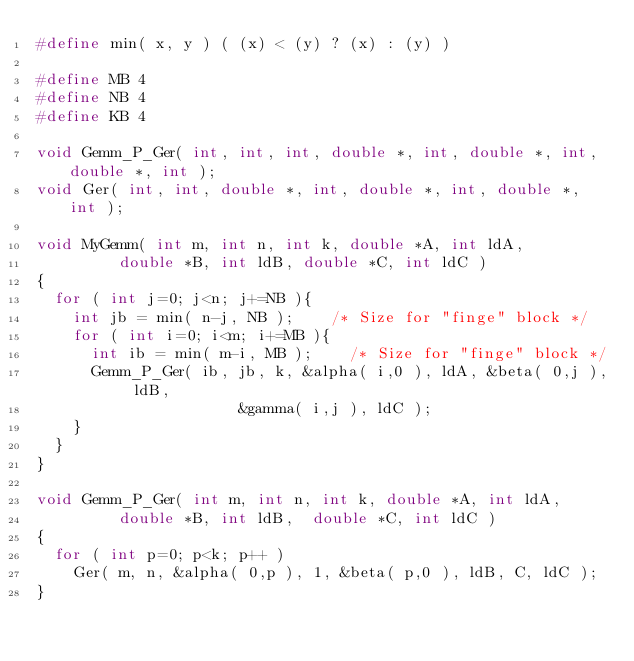Convert code to text. <code><loc_0><loc_0><loc_500><loc_500><_C_>#define min( x, y ) ( (x) < (y) ? (x) : (y) )

#define MB 4
#define NB 4
#define KB 4

void Gemm_P_Ger( int, int, int, double *, int, double *, int, double *, int );
void Ger( int, int, double *, int, double *, int, double *, int );

void MyGemm( int m, int n, int k, double *A, int ldA,
	     double *B, int ldB, double *C, int ldC )
{
  for ( int j=0; j<n; j+=NB ){
    int jb = min( n-j, NB );    /* Size for "finge" block */ 
    for ( int i=0; i<m; i+=MB ){
      int ib = min( m-i, MB );    /* Size for "finge" block */ 
      Gemm_P_Ger( ib, jb, k, &alpha( i,0 ), ldA, &beta( 0,j ), ldB,
	                  &gamma( i,j ), ldC );
    }
  }
}

void Gemm_P_Ger( int m, int n, int k, double *A, int ldA, 
		 double *B, int ldB,  double *C, int ldC )
{
  for ( int p=0; p<k; p++ )
    Ger( m, n, &alpha( 0,p ), 1, &beta( p,0 ), ldB, C, ldC );
}
</code> 